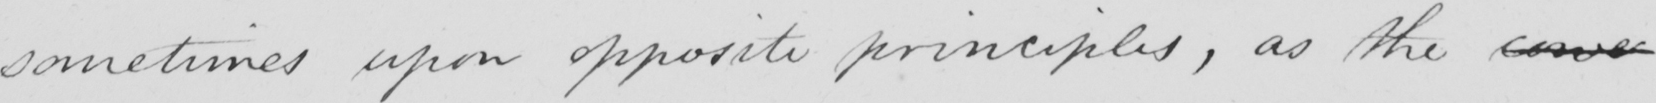What text is written in this handwritten line? sometimes upon opposite principles, as the cove 